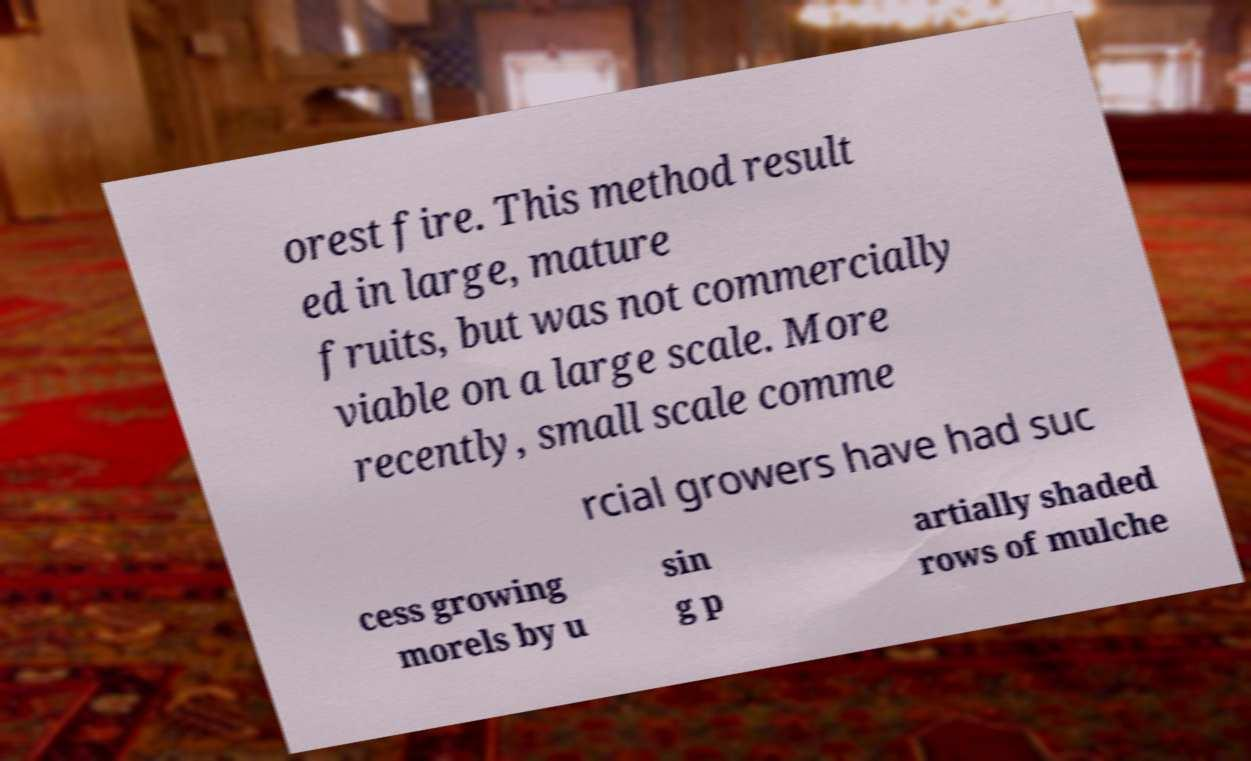What messages or text are displayed in this image? I need them in a readable, typed format. orest fire. This method result ed in large, mature fruits, but was not commercially viable on a large scale. More recently, small scale comme rcial growers have had suc cess growing morels by u sin g p artially shaded rows of mulche 